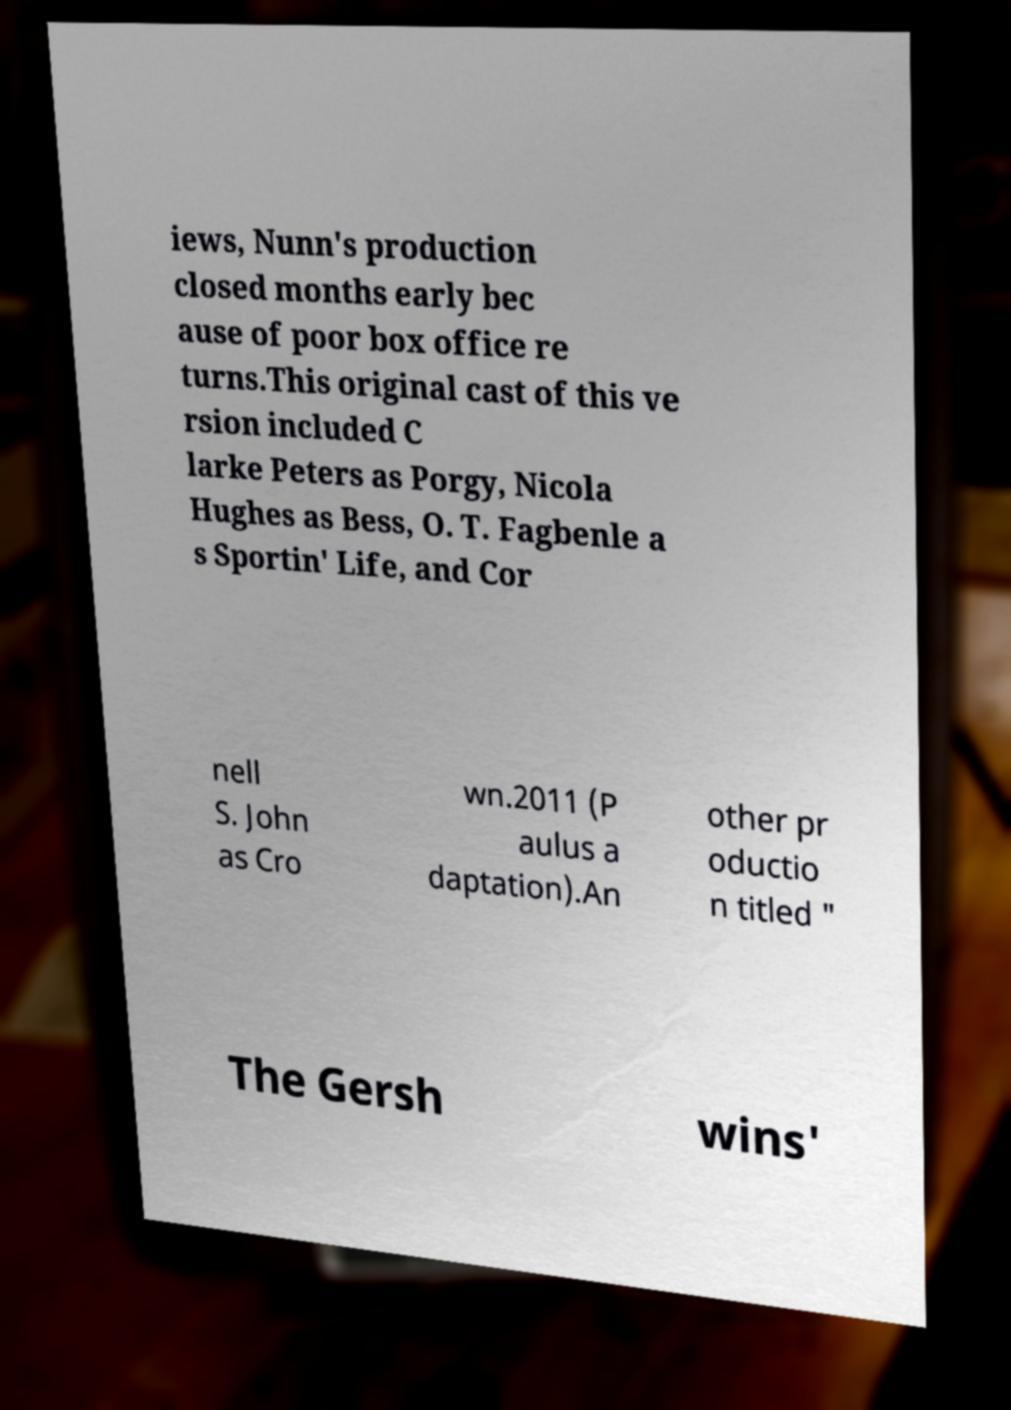Can you accurately transcribe the text from the provided image for me? iews, Nunn's production closed months early bec ause of poor box office re turns.This original cast of this ve rsion included C larke Peters as Porgy, Nicola Hughes as Bess, O. T. Fagbenle a s Sportin' Life, and Cor nell S. John as Cro wn.2011 (P aulus a daptation).An other pr oductio n titled " The Gersh wins' 